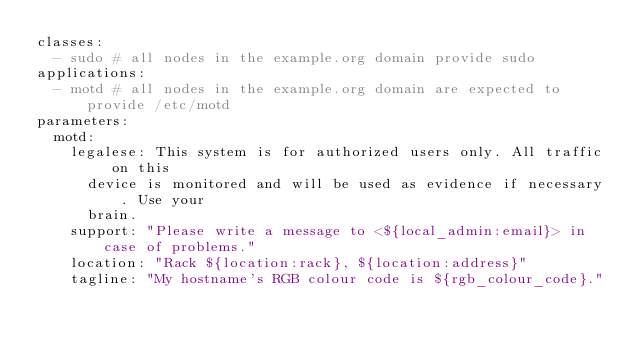Convert code to text. <code><loc_0><loc_0><loc_500><loc_500><_YAML_>classes:
  - sudo # all nodes in the example.org domain provide sudo
applications:
  - motd # all nodes in the example.org domain are expected to provide /etc/motd
parameters:
  motd:
    legalese: This system is for authorized users only. All traffic on this
      device is monitored and will be used as evidence if necessary. Use your
      brain.
    support: "Please write a message to <${local_admin:email}> in case of problems."
    location: "Rack ${location:rack}, ${location:address}"
    tagline: "My hostname's RGB colour code is ${rgb_colour_code}."
</code> 